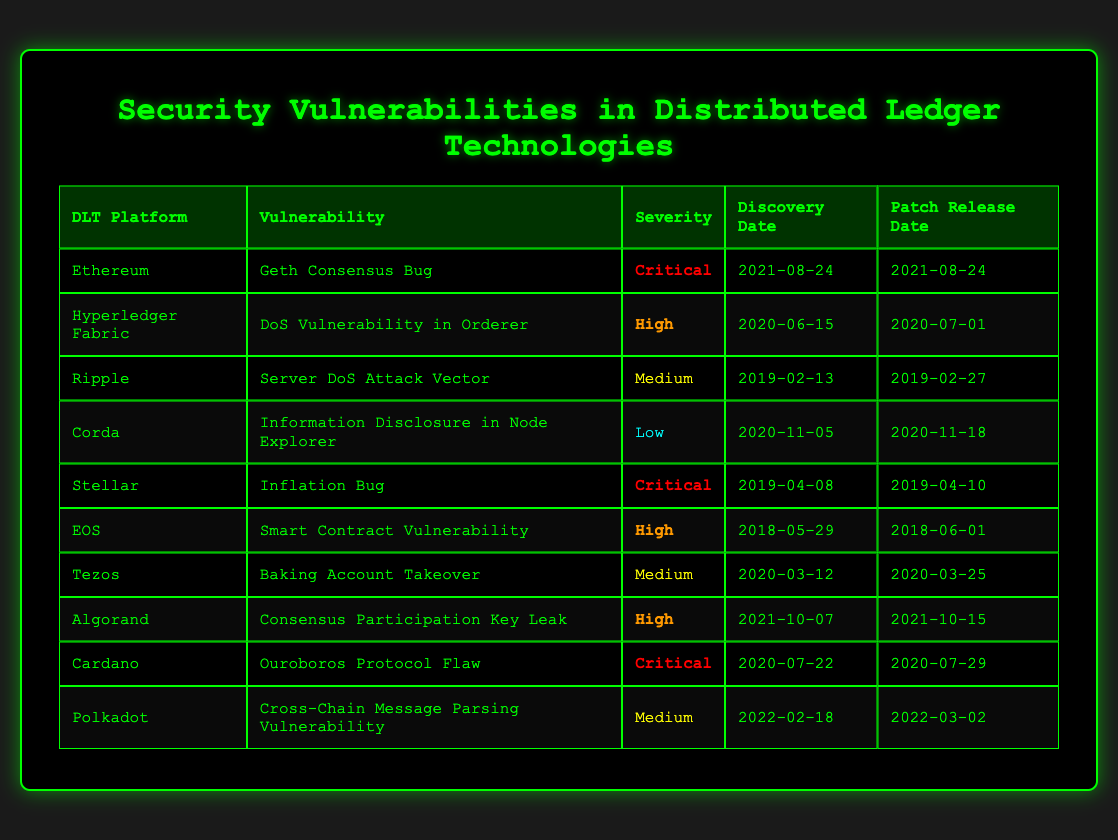What are the vulnerabilities listed for Ethereum? The table shows that Ethereum has one vulnerability listed, which is the "Geth Consensus Bug."
Answer: Geth Consensus Bug Which distributed ledger technology has the highest severity level vulnerability? The table indicates that Ethereum, Stellar, and Cardano each have a vulnerability classified as "Critical," making them the highest severity level vulnerabilities in the table.
Answer: Ethereum, Stellar, Cardano On what date was the "DoS Vulnerability in Orderer" discovered? By scanning the table, we find that the "DoS Vulnerability in Orderer" for Hyperledger Fabric was discovered on "2020-06-15."
Answer: 2020-06-15 How many vulnerabilities are classified as "Medium" severity? Looking at the table, there are three vulnerabilities categorized as "Medium": the "Server DoS Attack Vector" for Ripple, "Baking Account Takeover" for Tezos, and "Cross-Chain Message Parsing Vulnerability" for Polkadot. Therefore, the total count is three.
Answer: 3 Was the "Inflation Bug" in Stellar discovered before or after the "Ouroboros Protocol Flaw" in Cardano? The discovery date for the "Inflation Bug" in Stellar is "2019-04-08" and for the "Ouroboros Protocol Flaw," it is "2020-07-22." Since "2019-04-08" is before "2020-07-22," we can conclude that it was discovered before.
Answer: Before How much time elapsed between the discovery and patch release for the "Server DoS Attack Vector" in Ripple? The vulnerability was discovered on "2019-02-13" and patched on "2019-02-27," which gives a time difference of 14 days (from the 13th to the 27th inclusive).
Answer: 14 days Is there any high severity vulnerability that was patched after July 2020? Scanning the table shows that the "Consensus Participation Key Leak" for Algorand was discovered on "2021-10-07" and patched on "2021-10-15," which falls after July 2020. Therefore, there is indeed a high severity vulnerability that meets this criterion.
Answer: Yes What is the average severity level of vulnerabilities listed in the table? The table shows four severity levels: Critical (3), High (4), Medium (3), and Low (1). To express each severity level numerically (Critical=4, High=3, Medium=2, Low=1), we calculate the weighted average: (3*4 + 4*3 + 3*2 + 1*1) / (3 + 4 + 3 + 1) = (12 + 12 + 6 + 1) / 11 = 31 / 11, which is approximately 2.82, corresponding to "Medium."
Answer: Medium 